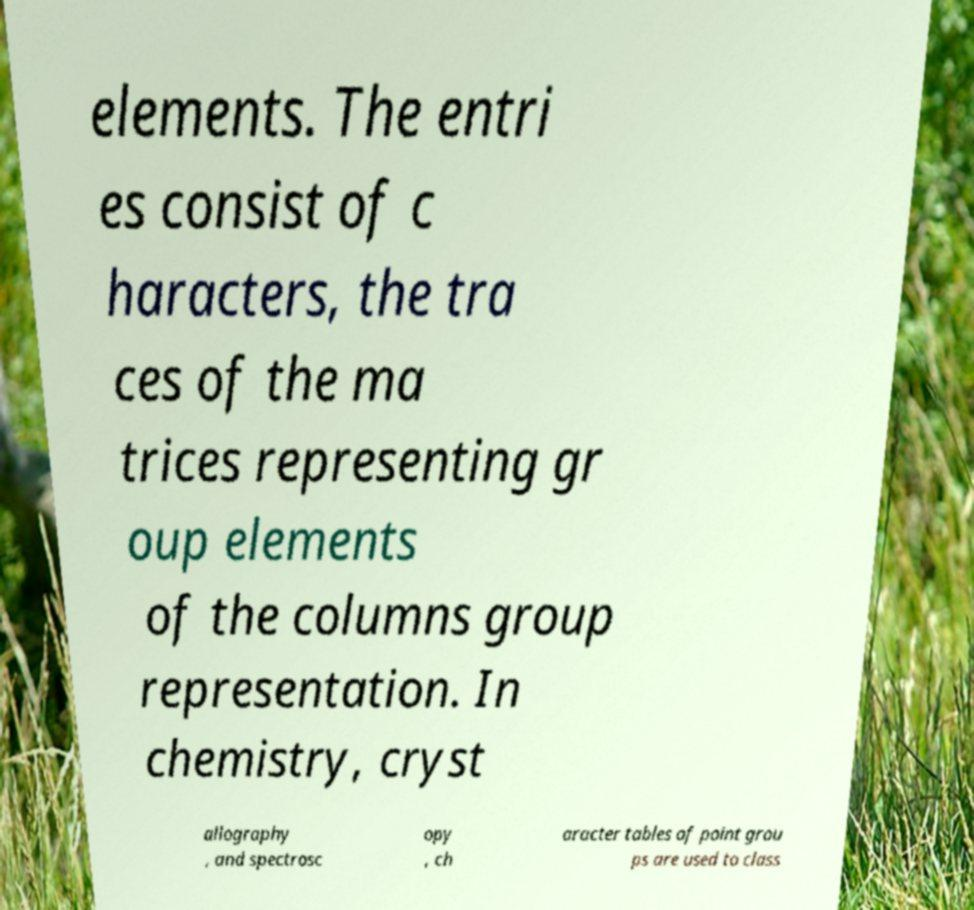Can you read and provide the text displayed in the image?This photo seems to have some interesting text. Can you extract and type it out for me? elements. The entri es consist of c haracters, the tra ces of the ma trices representing gr oup elements of the columns group representation. In chemistry, cryst allography , and spectrosc opy , ch aracter tables of point grou ps are used to class 